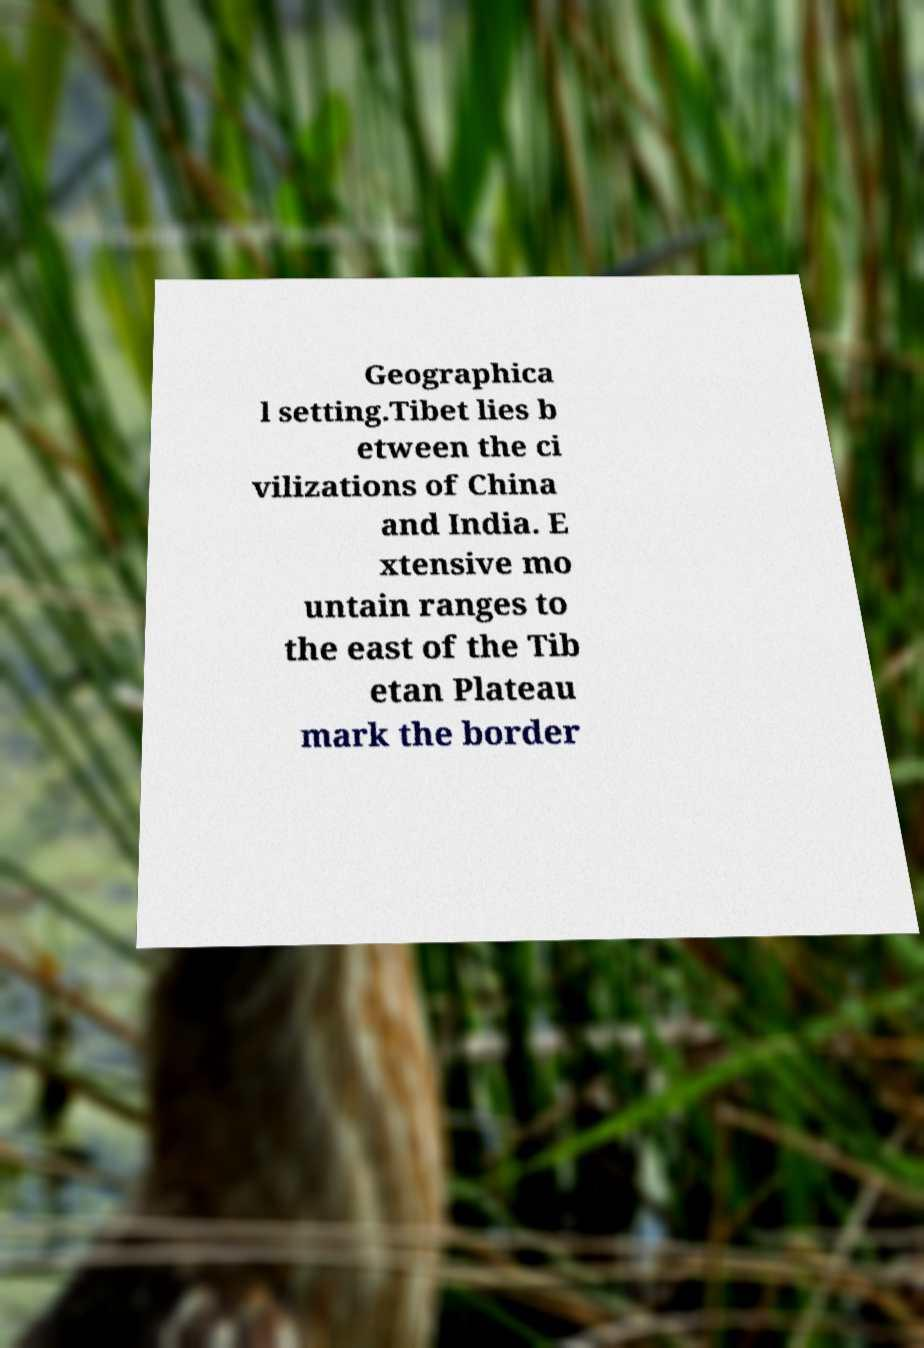Please identify and transcribe the text found in this image. Geographica l setting.Tibet lies b etween the ci vilizations of China and India. E xtensive mo untain ranges to the east of the Tib etan Plateau mark the border 